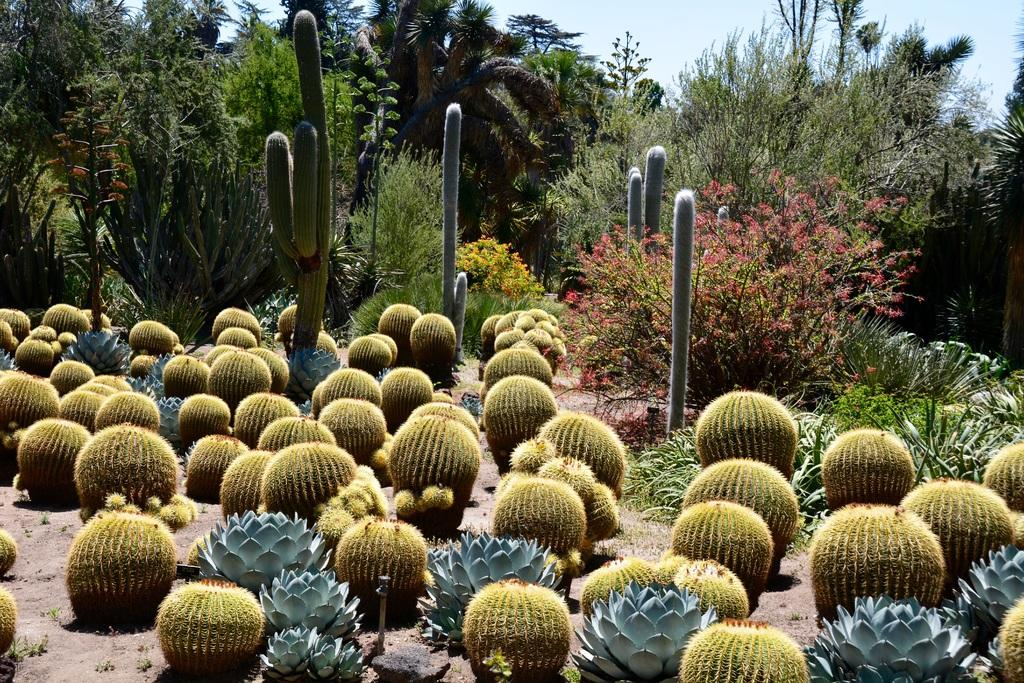What type of plants are visible on the ground in the image? There are desert plants on the ground in the image. What can be seen in the background of the image? There are trees and the sky visible in the background of the image. How many hens are perched on the branches of the trees in the image? There are no hens present in the image; it only features desert plants, trees, and the sky. 